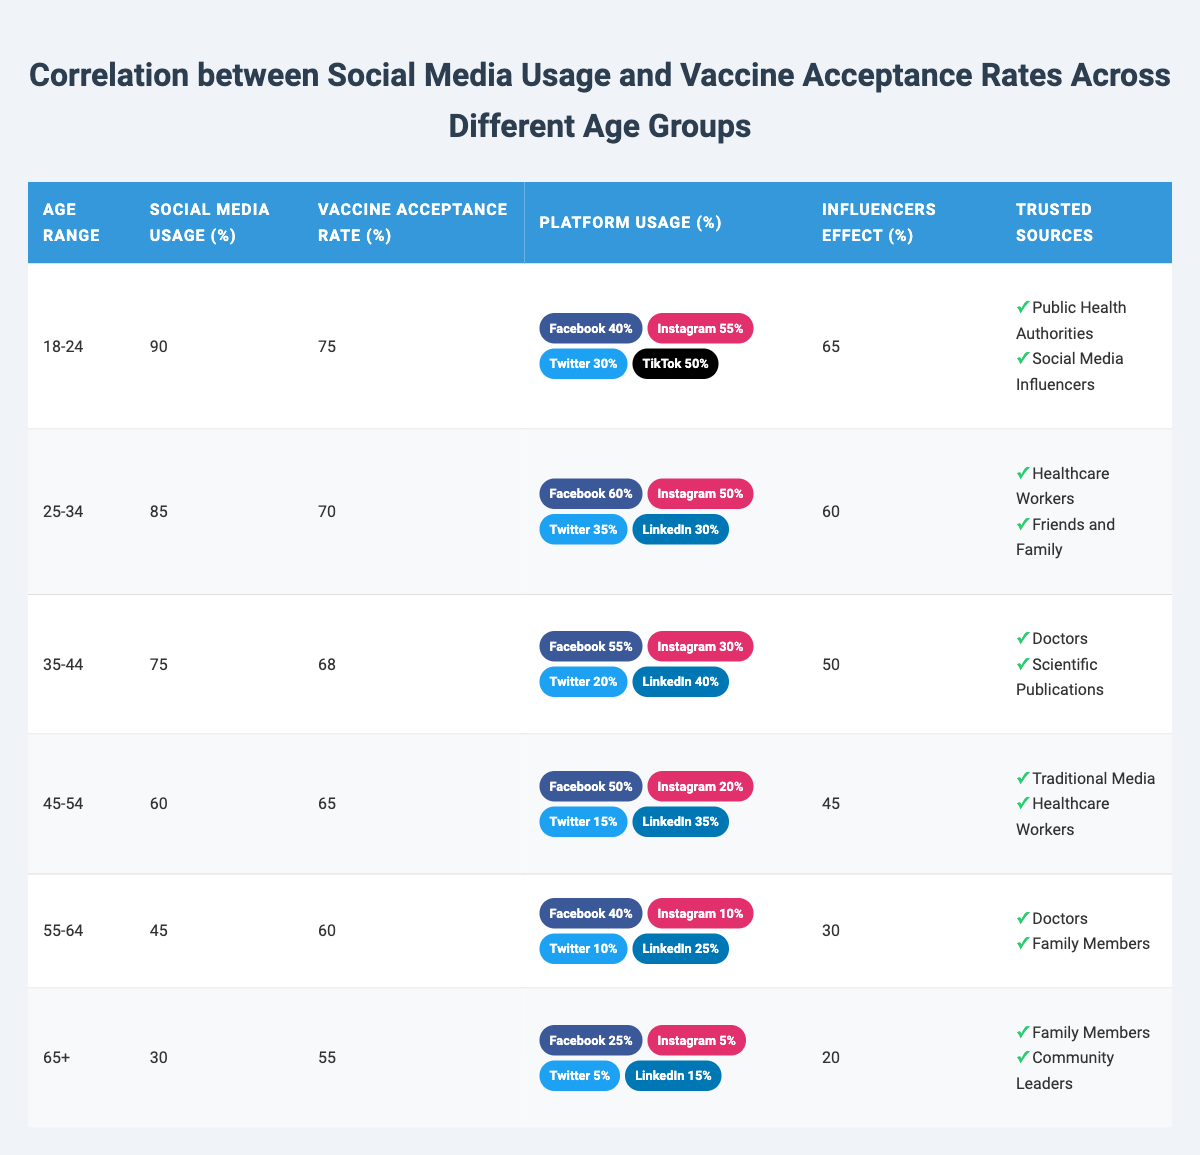What is the social media usage percentage for the age group 35-44? In the table, under the age group 35-44, the column for social media usage percentage shows a value of 75%.
Answer: 75% Which age group has the highest vaccine acceptance rate? By looking at the vaccine acceptance rate column, the age group 18-24 shows the highest value of 75%.
Answer: 18-24 What is the difference in social media usage percentage between the age groups 18-24 and 55-64? The social media usage for age group 18-24 is 90% and for age group 55-64 is 45%. The difference is 90% - 45% = 45%.
Answer: 45% Which age group trusts "Doctors" as a trusted source for vaccine information? The age groups 35-44 and 55-64 both list "Doctors" as a trusted source in their respective rows in the table.
Answer: 35-44 and 55-64 What is the average vaccine acceptance rate across all age groups? The vaccine acceptance rates for all age groups are: 75, 70, 68, 65, 60, and 55. Their total is 75 + 70 + 68 + 65 + 60 + 55 = 393, and there are 6 groups. So, the average is 393/6 = 65.5.
Answer: 65.5 Is the influencers effect higher in the age group 25-34 than in the age group 45-54? The influencers effect for age group 25-34 is 60, while for age group 45-54 it is 45. Since 60 is greater than 45, the statement is true.
Answer: Yes How many platforms did the age group 18-24 indicate as usage percentages in total? The age group 18-24 listed four platforms with the following percentages: Facebook 40%, Instagram 55%, Twitter 30%, TikTok 50%. Adding these gives 40 + 55 + 30 + 50 = 175%.
Answer: 175% What can be inferred about the decreasing trend of vaccine acceptance rates as the age group increases? Observing the vaccine acceptance rates in the table, it shows that younger age groups (18-24, 25-34) have rates above 70%, whereas older age groups (55-64, 65+) show lower rates of 60% and 55%. This indicates a declining trend in vaccine acceptance with increasing age.
Answer: Decreasing trend in vaccine acceptance What percentage of the 65+ age group uses social media compared to the 18-24 age group? The 65+ age group's social media usage is 30% compared to 90% for the 18-24 age group. The difference is 90% - 30% = 60%, which shows a significant gap.
Answer: 60% difference Which platforms are less utilized by the age group 55-64, based on the table? Based on the table, the age group 55-64 has low utilization percentages on Instagram (10%) and Twitter (10%).
Answer: Instagram and Twitter 